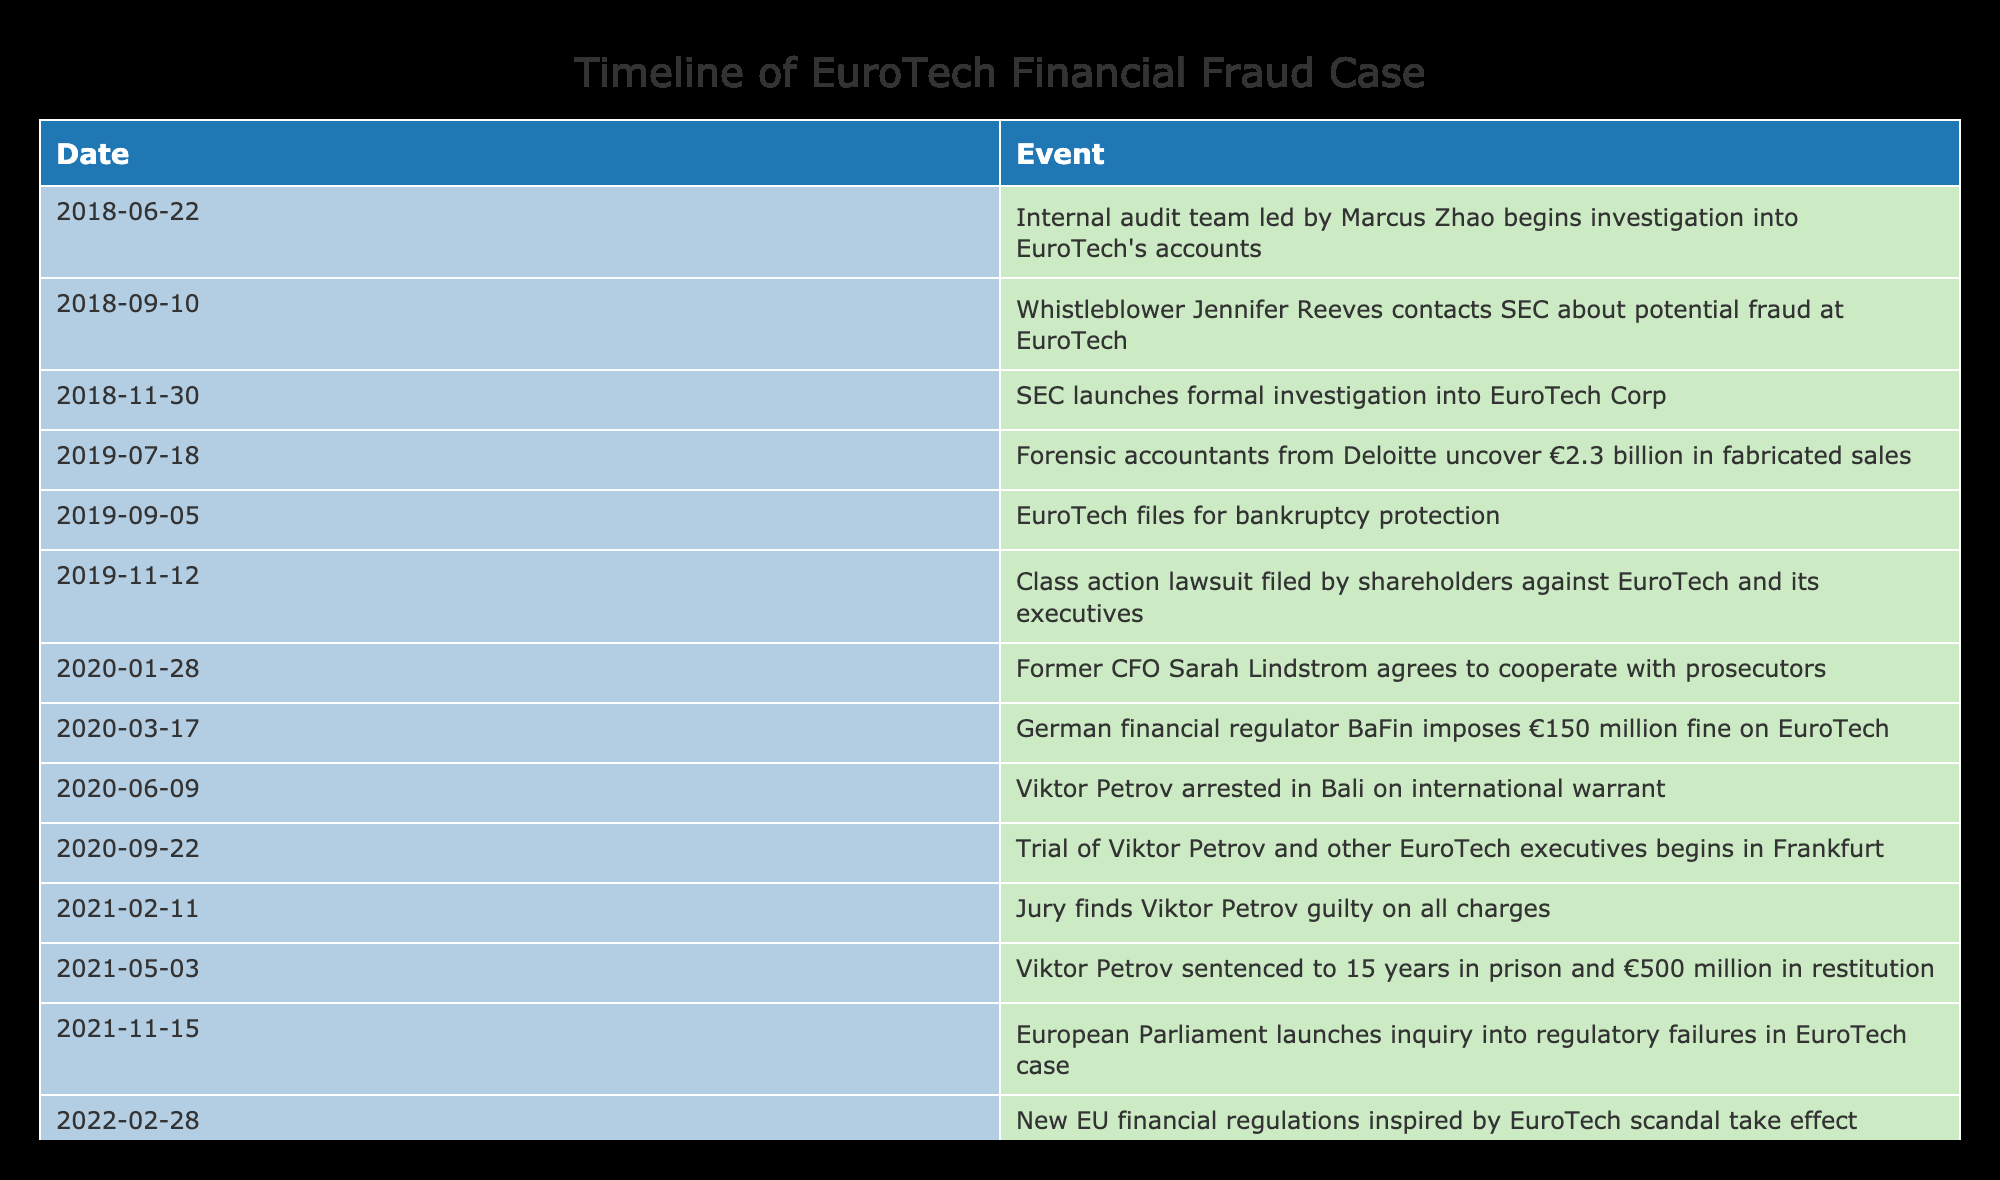What date did the SEC launch a formal investigation into EuroTech Corp? The table indicates that the SEC launched a formal investigation into EuroTech Corp on the date 2018-11-30. This information can be directly retrieved from the corresponding row in the table.
Answer: 2018-11-30 Who was arrested on an international warrant and when? According to the table, Viktor Petrov was arrested on an international warrant on the date 2020-06-09. This specific event can be found in the relevant row.
Answer: Viktor Petrov on 2020-06-09 How long did it take from the start of the investigation by the internal audit team to the arrest of Viktor Petrov? The internal audit team began their investigation on 2018-06-22 and Viktor Petrov was arrested on 2020-06-09. To find the duration, calculate the difference between these two dates. The duration is approximately 2 years.
Answer: 2 years Was there a class action lawsuit filed against EuroTech before Viktor Petrov was sentenced? The table shows that the class action lawsuit was filed on 2019-11-12, while Viktor Petrov was sentenced on 2021-05-03. Since 2019-11-12 comes before 2021-05-03, this statement is true.
Answer: Yes What is the total span of time from the initial audit investigation to the European Parliament's inquiry launch? The initial audit investigation started on 2018-06-22 and the inquiry by the European Parliament was launched on 2021-11-15. To find the total span, calculate the difference between these two dates. The total span is approximately 3 years and 5 months.
Answer: 3 years and 5 months What major event occurred on 2020-01-28? The table indicates that on 2020-01-28, former CFO Sarah Lindstrom agreed to cooperate with prosecutors. This specific event can be directly retrieved from the relevant row in the table.
Answer: Sarah Lindstrom agreed to cooperate with prosecutors How many months were there between the arrest of Viktor Petrov and the trial beginning? Viktor Petrov was arrested on 2020-06-09 and his trial began on 2020-09-22. To find the months in between, count from June to September which is approximately 3 months.
Answer: 3 months Was the €150 million fine imposed on EuroTech before or after the fraud amount was uncovered by the forensic accountants? The fraud amount of €2.3 billion was uncovered on 2019-07-18, and the fine was imposed on 2020-03-17. Since 2020 comes after 2019, this is true.
Answer: After 